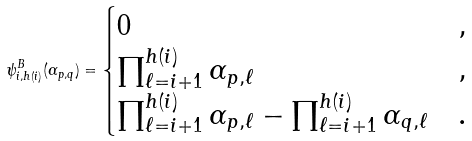<formula> <loc_0><loc_0><loc_500><loc_500>\psi _ { i , h ( i ) } ^ { B } ( \alpha _ { p , q } ) = \begin{cases} 0 & , \\ \prod _ { \ell = i + 1 } ^ { h ( i ) } \alpha _ { p , \ell } & , \\ \prod _ { \ell = i + 1 } ^ { h ( i ) } \alpha _ { p , \ell } - \prod _ { \ell = i + 1 } ^ { h ( i ) } \alpha _ { q , \ell } & . \end{cases}</formula> 